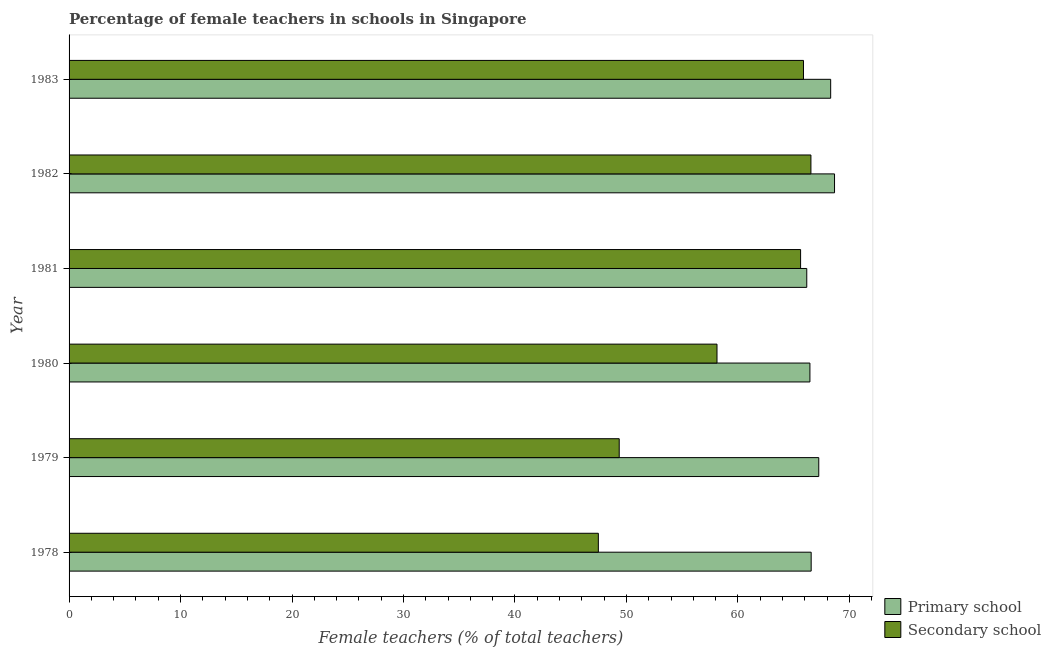How many different coloured bars are there?
Keep it short and to the point. 2. Are the number of bars per tick equal to the number of legend labels?
Provide a succinct answer. Yes. Are the number of bars on each tick of the Y-axis equal?
Make the answer very short. Yes. In how many cases, is the number of bars for a given year not equal to the number of legend labels?
Make the answer very short. 0. What is the percentage of female teachers in primary schools in 1979?
Your answer should be compact. 67.25. Across all years, what is the maximum percentage of female teachers in primary schools?
Offer a very short reply. 68.67. Across all years, what is the minimum percentage of female teachers in secondary schools?
Make the answer very short. 47.48. In which year was the percentage of female teachers in primary schools minimum?
Provide a short and direct response. 1981. What is the total percentage of female teachers in secondary schools in the graph?
Provide a short and direct response. 353. What is the difference between the percentage of female teachers in secondary schools in 1981 and that in 1982?
Provide a succinct answer. -0.93. What is the difference between the percentage of female teachers in secondary schools in 1979 and the percentage of female teachers in primary schools in 1980?
Keep it short and to the point. -17.11. What is the average percentage of female teachers in secondary schools per year?
Provide a succinct answer. 58.83. In the year 1978, what is the difference between the percentage of female teachers in primary schools and percentage of female teachers in secondary schools?
Ensure brevity in your answer.  19.09. What is the difference between the highest and the second highest percentage of female teachers in secondary schools?
Offer a very short reply. 0.67. What is the difference between the highest and the lowest percentage of female teachers in secondary schools?
Give a very brief answer. 19.07. In how many years, is the percentage of female teachers in secondary schools greater than the average percentage of female teachers in secondary schools taken over all years?
Provide a succinct answer. 3. Is the sum of the percentage of female teachers in secondary schools in 1978 and 1981 greater than the maximum percentage of female teachers in primary schools across all years?
Your answer should be very brief. Yes. What does the 1st bar from the top in 1979 represents?
Give a very brief answer. Secondary school. What does the 2nd bar from the bottom in 1978 represents?
Provide a short and direct response. Secondary school. How many bars are there?
Give a very brief answer. 12. Are all the bars in the graph horizontal?
Provide a succinct answer. Yes. What is the difference between two consecutive major ticks on the X-axis?
Your answer should be compact. 10. Are the values on the major ticks of X-axis written in scientific E-notation?
Keep it short and to the point. No. Does the graph contain any zero values?
Your answer should be very brief. No. Does the graph contain grids?
Your response must be concise. No. How many legend labels are there?
Make the answer very short. 2. How are the legend labels stacked?
Offer a terse response. Vertical. What is the title of the graph?
Your answer should be very brief. Percentage of female teachers in schools in Singapore. What is the label or title of the X-axis?
Provide a short and direct response. Female teachers (% of total teachers). What is the Female teachers (% of total teachers) in Primary school in 1978?
Provide a succinct answer. 66.57. What is the Female teachers (% of total teachers) of Secondary school in 1978?
Your response must be concise. 47.48. What is the Female teachers (% of total teachers) of Primary school in 1979?
Offer a terse response. 67.25. What is the Female teachers (% of total teachers) of Secondary school in 1979?
Offer a terse response. 49.35. What is the Female teachers (% of total teachers) in Primary school in 1980?
Your answer should be compact. 66.46. What is the Female teachers (% of total teachers) in Secondary school in 1980?
Give a very brief answer. 58.12. What is the Female teachers (% of total teachers) of Primary school in 1981?
Your answer should be very brief. 66.18. What is the Female teachers (% of total teachers) in Secondary school in 1981?
Provide a short and direct response. 65.62. What is the Female teachers (% of total teachers) of Primary school in 1982?
Offer a terse response. 68.67. What is the Female teachers (% of total teachers) of Secondary school in 1982?
Your answer should be compact. 66.55. What is the Female teachers (% of total teachers) of Primary school in 1983?
Your answer should be compact. 68.32. What is the Female teachers (% of total teachers) in Secondary school in 1983?
Keep it short and to the point. 65.88. Across all years, what is the maximum Female teachers (% of total teachers) of Primary school?
Your answer should be very brief. 68.67. Across all years, what is the maximum Female teachers (% of total teachers) of Secondary school?
Your answer should be compact. 66.55. Across all years, what is the minimum Female teachers (% of total teachers) of Primary school?
Provide a short and direct response. 66.18. Across all years, what is the minimum Female teachers (% of total teachers) in Secondary school?
Your response must be concise. 47.48. What is the total Female teachers (% of total teachers) of Primary school in the graph?
Ensure brevity in your answer.  403.44. What is the total Female teachers (% of total teachers) of Secondary school in the graph?
Ensure brevity in your answer.  353. What is the difference between the Female teachers (% of total teachers) of Primary school in 1978 and that in 1979?
Your response must be concise. -0.68. What is the difference between the Female teachers (% of total teachers) in Secondary school in 1978 and that in 1979?
Offer a terse response. -1.87. What is the difference between the Female teachers (% of total teachers) in Primary school in 1978 and that in 1980?
Provide a succinct answer. 0.11. What is the difference between the Female teachers (% of total teachers) in Secondary school in 1978 and that in 1980?
Make the answer very short. -10.65. What is the difference between the Female teachers (% of total teachers) of Primary school in 1978 and that in 1981?
Your answer should be compact. 0.39. What is the difference between the Female teachers (% of total teachers) in Secondary school in 1978 and that in 1981?
Provide a succinct answer. -18.14. What is the difference between the Female teachers (% of total teachers) of Primary school in 1978 and that in 1982?
Make the answer very short. -2.1. What is the difference between the Female teachers (% of total teachers) in Secondary school in 1978 and that in 1982?
Make the answer very short. -19.07. What is the difference between the Female teachers (% of total teachers) of Primary school in 1978 and that in 1983?
Provide a short and direct response. -1.75. What is the difference between the Female teachers (% of total teachers) in Secondary school in 1978 and that in 1983?
Make the answer very short. -18.4. What is the difference between the Female teachers (% of total teachers) in Primary school in 1979 and that in 1980?
Provide a short and direct response. 0.79. What is the difference between the Female teachers (% of total teachers) of Secondary school in 1979 and that in 1980?
Your response must be concise. -8.77. What is the difference between the Female teachers (% of total teachers) of Primary school in 1979 and that in 1981?
Your response must be concise. 1.08. What is the difference between the Female teachers (% of total teachers) of Secondary school in 1979 and that in 1981?
Give a very brief answer. -16.27. What is the difference between the Female teachers (% of total teachers) of Primary school in 1979 and that in 1982?
Provide a short and direct response. -1.41. What is the difference between the Female teachers (% of total teachers) in Secondary school in 1979 and that in 1982?
Your answer should be compact. -17.2. What is the difference between the Female teachers (% of total teachers) of Primary school in 1979 and that in 1983?
Your answer should be very brief. -1.07. What is the difference between the Female teachers (% of total teachers) in Secondary school in 1979 and that in 1983?
Make the answer very short. -16.53. What is the difference between the Female teachers (% of total teachers) in Primary school in 1980 and that in 1981?
Make the answer very short. 0.28. What is the difference between the Female teachers (% of total teachers) in Secondary school in 1980 and that in 1981?
Provide a short and direct response. -7.5. What is the difference between the Female teachers (% of total teachers) in Primary school in 1980 and that in 1982?
Provide a short and direct response. -2.21. What is the difference between the Female teachers (% of total teachers) of Secondary school in 1980 and that in 1982?
Offer a very short reply. -8.43. What is the difference between the Female teachers (% of total teachers) of Primary school in 1980 and that in 1983?
Provide a succinct answer. -1.86. What is the difference between the Female teachers (% of total teachers) in Secondary school in 1980 and that in 1983?
Keep it short and to the point. -7.76. What is the difference between the Female teachers (% of total teachers) in Primary school in 1981 and that in 1982?
Provide a short and direct response. -2.49. What is the difference between the Female teachers (% of total teachers) of Secondary school in 1981 and that in 1982?
Make the answer very short. -0.93. What is the difference between the Female teachers (% of total teachers) in Primary school in 1981 and that in 1983?
Your answer should be very brief. -2.14. What is the difference between the Female teachers (% of total teachers) of Secondary school in 1981 and that in 1983?
Your response must be concise. -0.26. What is the difference between the Female teachers (% of total teachers) of Primary school in 1982 and that in 1983?
Your response must be concise. 0.35. What is the difference between the Female teachers (% of total teachers) in Secondary school in 1982 and that in 1983?
Offer a very short reply. 0.67. What is the difference between the Female teachers (% of total teachers) in Primary school in 1978 and the Female teachers (% of total teachers) in Secondary school in 1979?
Make the answer very short. 17.22. What is the difference between the Female teachers (% of total teachers) of Primary school in 1978 and the Female teachers (% of total teachers) of Secondary school in 1980?
Provide a short and direct response. 8.45. What is the difference between the Female teachers (% of total teachers) in Primary school in 1978 and the Female teachers (% of total teachers) in Secondary school in 1981?
Make the answer very short. 0.95. What is the difference between the Female teachers (% of total teachers) of Primary school in 1978 and the Female teachers (% of total teachers) of Secondary school in 1982?
Keep it short and to the point. 0.02. What is the difference between the Female teachers (% of total teachers) of Primary school in 1978 and the Female teachers (% of total teachers) of Secondary school in 1983?
Your answer should be compact. 0.69. What is the difference between the Female teachers (% of total teachers) of Primary school in 1979 and the Female teachers (% of total teachers) of Secondary school in 1980?
Your response must be concise. 9.13. What is the difference between the Female teachers (% of total teachers) in Primary school in 1979 and the Female teachers (% of total teachers) in Secondary school in 1981?
Your answer should be very brief. 1.63. What is the difference between the Female teachers (% of total teachers) in Primary school in 1979 and the Female teachers (% of total teachers) in Secondary school in 1982?
Keep it short and to the point. 0.7. What is the difference between the Female teachers (% of total teachers) in Primary school in 1979 and the Female teachers (% of total teachers) in Secondary school in 1983?
Offer a very short reply. 1.37. What is the difference between the Female teachers (% of total teachers) of Primary school in 1980 and the Female teachers (% of total teachers) of Secondary school in 1981?
Give a very brief answer. 0.84. What is the difference between the Female teachers (% of total teachers) in Primary school in 1980 and the Female teachers (% of total teachers) in Secondary school in 1982?
Provide a short and direct response. -0.09. What is the difference between the Female teachers (% of total teachers) in Primary school in 1980 and the Female teachers (% of total teachers) in Secondary school in 1983?
Give a very brief answer. 0.58. What is the difference between the Female teachers (% of total teachers) of Primary school in 1981 and the Female teachers (% of total teachers) of Secondary school in 1982?
Provide a succinct answer. -0.37. What is the difference between the Female teachers (% of total teachers) in Primary school in 1981 and the Female teachers (% of total teachers) in Secondary school in 1983?
Your answer should be compact. 0.3. What is the difference between the Female teachers (% of total teachers) of Primary school in 1982 and the Female teachers (% of total teachers) of Secondary school in 1983?
Your response must be concise. 2.79. What is the average Female teachers (% of total teachers) in Primary school per year?
Give a very brief answer. 67.24. What is the average Female teachers (% of total teachers) in Secondary school per year?
Offer a very short reply. 58.83. In the year 1978, what is the difference between the Female teachers (% of total teachers) in Primary school and Female teachers (% of total teachers) in Secondary school?
Your answer should be compact. 19.09. In the year 1979, what is the difference between the Female teachers (% of total teachers) of Primary school and Female teachers (% of total teachers) of Secondary school?
Offer a very short reply. 17.9. In the year 1980, what is the difference between the Female teachers (% of total teachers) of Primary school and Female teachers (% of total teachers) of Secondary school?
Give a very brief answer. 8.34. In the year 1981, what is the difference between the Female teachers (% of total teachers) in Primary school and Female teachers (% of total teachers) in Secondary school?
Offer a very short reply. 0.55. In the year 1982, what is the difference between the Female teachers (% of total teachers) of Primary school and Female teachers (% of total teachers) of Secondary school?
Offer a terse response. 2.12. In the year 1983, what is the difference between the Female teachers (% of total teachers) in Primary school and Female teachers (% of total teachers) in Secondary school?
Offer a terse response. 2.44. What is the ratio of the Female teachers (% of total teachers) in Primary school in 1978 to that in 1979?
Your answer should be compact. 0.99. What is the ratio of the Female teachers (% of total teachers) in Primary school in 1978 to that in 1980?
Provide a succinct answer. 1. What is the ratio of the Female teachers (% of total teachers) of Secondary school in 1978 to that in 1980?
Give a very brief answer. 0.82. What is the ratio of the Female teachers (% of total teachers) in Primary school in 1978 to that in 1981?
Your response must be concise. 1.01. What is the ratio of the Female teachers (% of total teachers) in Secondary school in 1978 to that in 1981?
Provide a short and direct response. 0.72. What is the ratio of the Female teachers (% of total teachers) of Primary school in 1978 to that in 1982?
Your response must be concise. 0.97. What is the ratio of the Female teachers (% of total teachers) in Secondary school in 1978 to that in 1982?
Ensure brevity in your answer.  0.71. What is the ratio of the Female teachers (% of total teachers) of Primary school in 1978 to that in 1983?
Keep it short and to the point. 0.97. What is the ratio of the Female teachers (% of total teachers) in Secondary school in 1978 to that in 1983?
Your answer should be compact. 0.72. What is the ratio of the Female teachers (% of total teachers) in Primary school in 1979 to that in 1980?
Give a very brief answer. 1.01. What is the ratio of the Female teachers (% of total teachers) in Secondary school in 1979 to that in 1980?
Your answer should be very brief. 0.85. What is the ratio of the Female teachers (% of total teachers) in Primary school in 1979 to that in 1981?
Keep it short and to the point. 1.02. What is the ratio of the Female teachers (% of total teachers) in Secondary school in 1979 to that in 1981?
Give a very brief answer. 0.75. What is the ratio of the Female teachers (% of total teachers) in Primary school in 1979 to that in 1982?
Keep it short and to the point. 0.98. What is the ratio of the Female teachers (% of total teachers) of Secondary school in 1979 to that in 1982?
Your response must be concise. 0.74. What is the ratio of the Female teachers (% of total teachers) in Primary school in 1979 to that in 1983?
Ensure brevity in your answer.  0.98. What is the ratio of the Female teachers (% of total teachers) in Secondary school in 1979 to that in 1983?
Your response must be concise. 0.75. What is the ratio of the Female teachers (% of total teachers) in Primary school in 1980 to that in 1981?
Your response must be concise. 1. What is the ratio of the Female teachers (% of total teachers) in Secondary school in 1980 to that in 1981?
Keep it short and to the point. 0.89. What is the ratio of the Female teachers (% of total teachers) in Primary school in 1980 to that in 1982?
Offer a very short reply. 0.97. What is the ratio of the Female teachers (% of total teachers) in Secondary school in 1980 to that in 1982?
Keep it short and to the point. 0.87. What is the ratio of the Female teachers (% of total teachers) of Primary school in 1980 to that in 1983?
Your answer should be very brief. 0.97. What is the ratio of the Female teachers (% of total teachers) of Secondary school in 1980 to that in 1983?
Offer a terse response. 0.88. What is the ratio of the Female teachers (% of total teachers) of Primary school in 1981 to that in 1982?
Make the answer very short. 0.96. What is the ratio of the Female teachers (% of total teachers) in Secondary school in 1981 to that in 1982?
Offer a very short reply. 0.99. What is the ratio of the Female teachers (% of total teachers) in Primary school in 1981 to that in 1983?
Ensure brevity in your answer.  0.97. What is the difference between the highest and the second highest Female teachers (% of total teachers) of Primary school?
Give a very brief answer. 0.35. What is the difference between the highest and the second highest Female teachers (% of total teachers) of Secondary school?
Provide a succinct answer. 0.67. What is the difference between the highest and the lowest Female teachers (% of total teachers) of Primary school?
Make the answer very short. 2.49. What is the difference between the highest and the lowest Female teachers (% of total teachers) in Secondary school?
Provide a succinct answer. 19.07. 